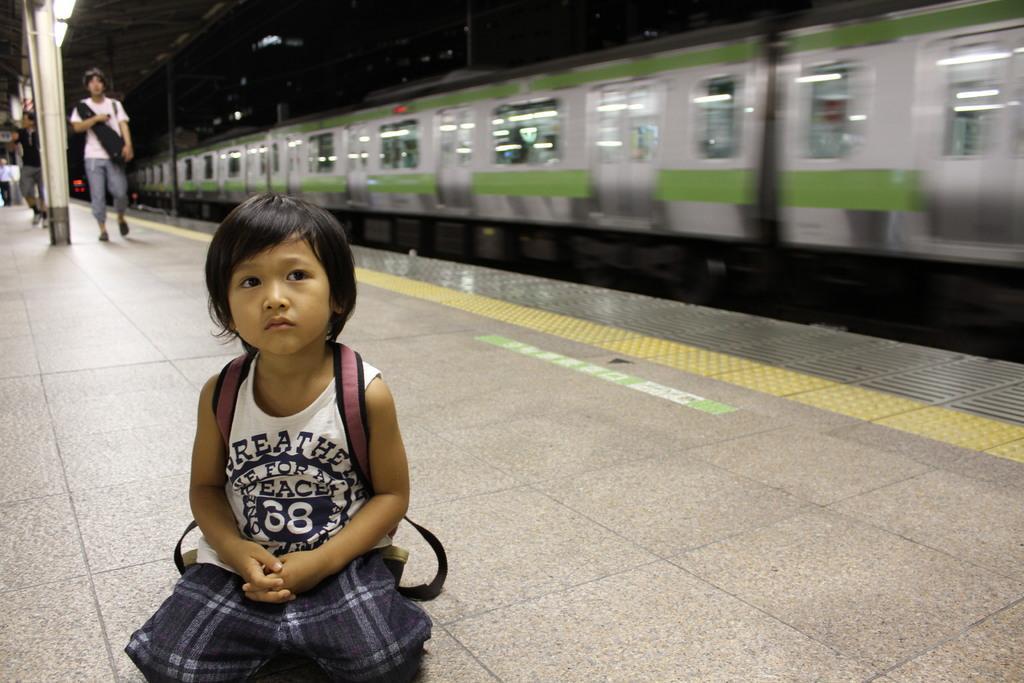Can you describe this image briefly? In this image there is a kid who is kneeling down on the platform. Behind the kid there is a train on the railway track. On the left side there are few people walking on the platform. At the top of the platform there are lights. 